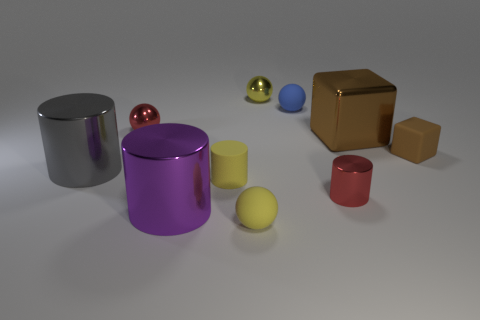Subtract 1 balls. How many balls are left? 3 Subtract all blocks. How many objects are left? 8 Add 9 small purple things. How many small purple things exist? 9 Subtract 1 red balls. How many objects are left? 9 Subtract all small yellow matte cylinders. Subtract all tiny red metal spheres. How many objects are left? 8 Add 4 yellow cylinders. How many yellow cylinders are left? 5 